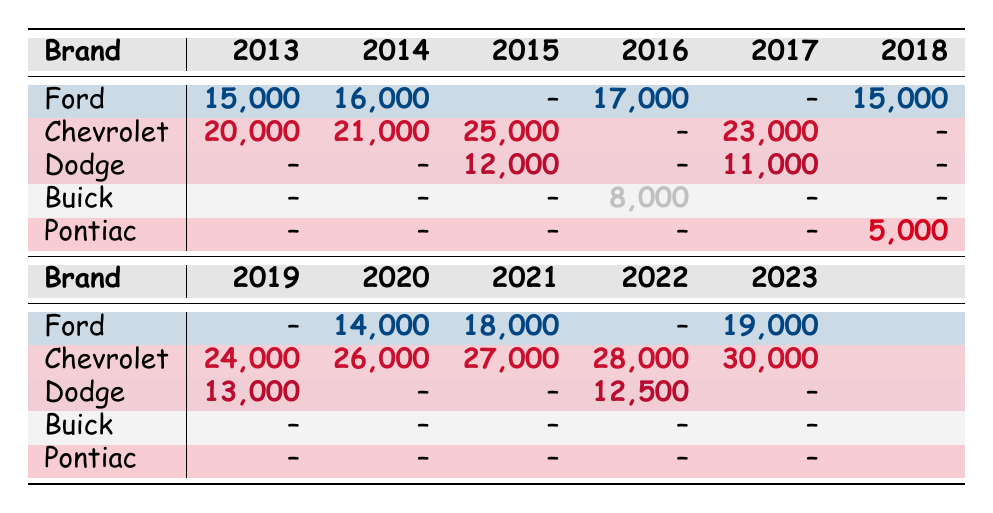What were the sales numbers for Chevrolet in 2022? Referring to the table, under the year 2022, the sales for Chevrolet are listed as 28,000.
Answer: 28,000 Which brand had the highest sales in 2023? By checking the sales numbers for each brand in 2023, we see that Chevrolet had sales of 30,000, which is higher than Ford’s 19,000.
Answer: Chevrolet How much did Ford's sales increase from 2013 to 2021? For Ford, the sales in 2013 were 15,000 and in 2021 were 18,000. The increase is calculated by subtracting 15,000 from 18,000, resulting in an increase of 3,000.
Answer: 3,000 Did Dodge achieve sales in every year represented in the table? A review of the table shows that Dodge had sales recorded for 2015, 2017, 2019, and 2022, thus missing sales data for 2013, 2014, 2016, 2018, and 2020, which confirms that it did not achieve sales every year.
Answer: No What is the average number of sales for Chevrolet over the years it appears in the table? Chevrolet's sales numbers are: 20,000 (2013), 21,000 (2014), 25,000 (2015), 23,000 (2017), 24,000 (2019), 26,000 (2020), 27,000 (2021), 28,000 (2022), and 30,000 (2023). Summing these gives 24,000 and dividing by 9 (the number of years) results in an average of 24,222.
Answer: 24,222 In which year did Pontiac have sales, and what was that figure? The table indicates Pontiac had sales only in the year 2018, and that figure is 5,000.
Answer: 5,000 Which brand had the lowest sales in 2016, and what were those sales? In the year 2016, Buick recorded sales of 8,000, while all other brands either had no sales listed or reported higher sales. Therefore, Buick had the lowest sales.
Answer: Buick, 8,000 